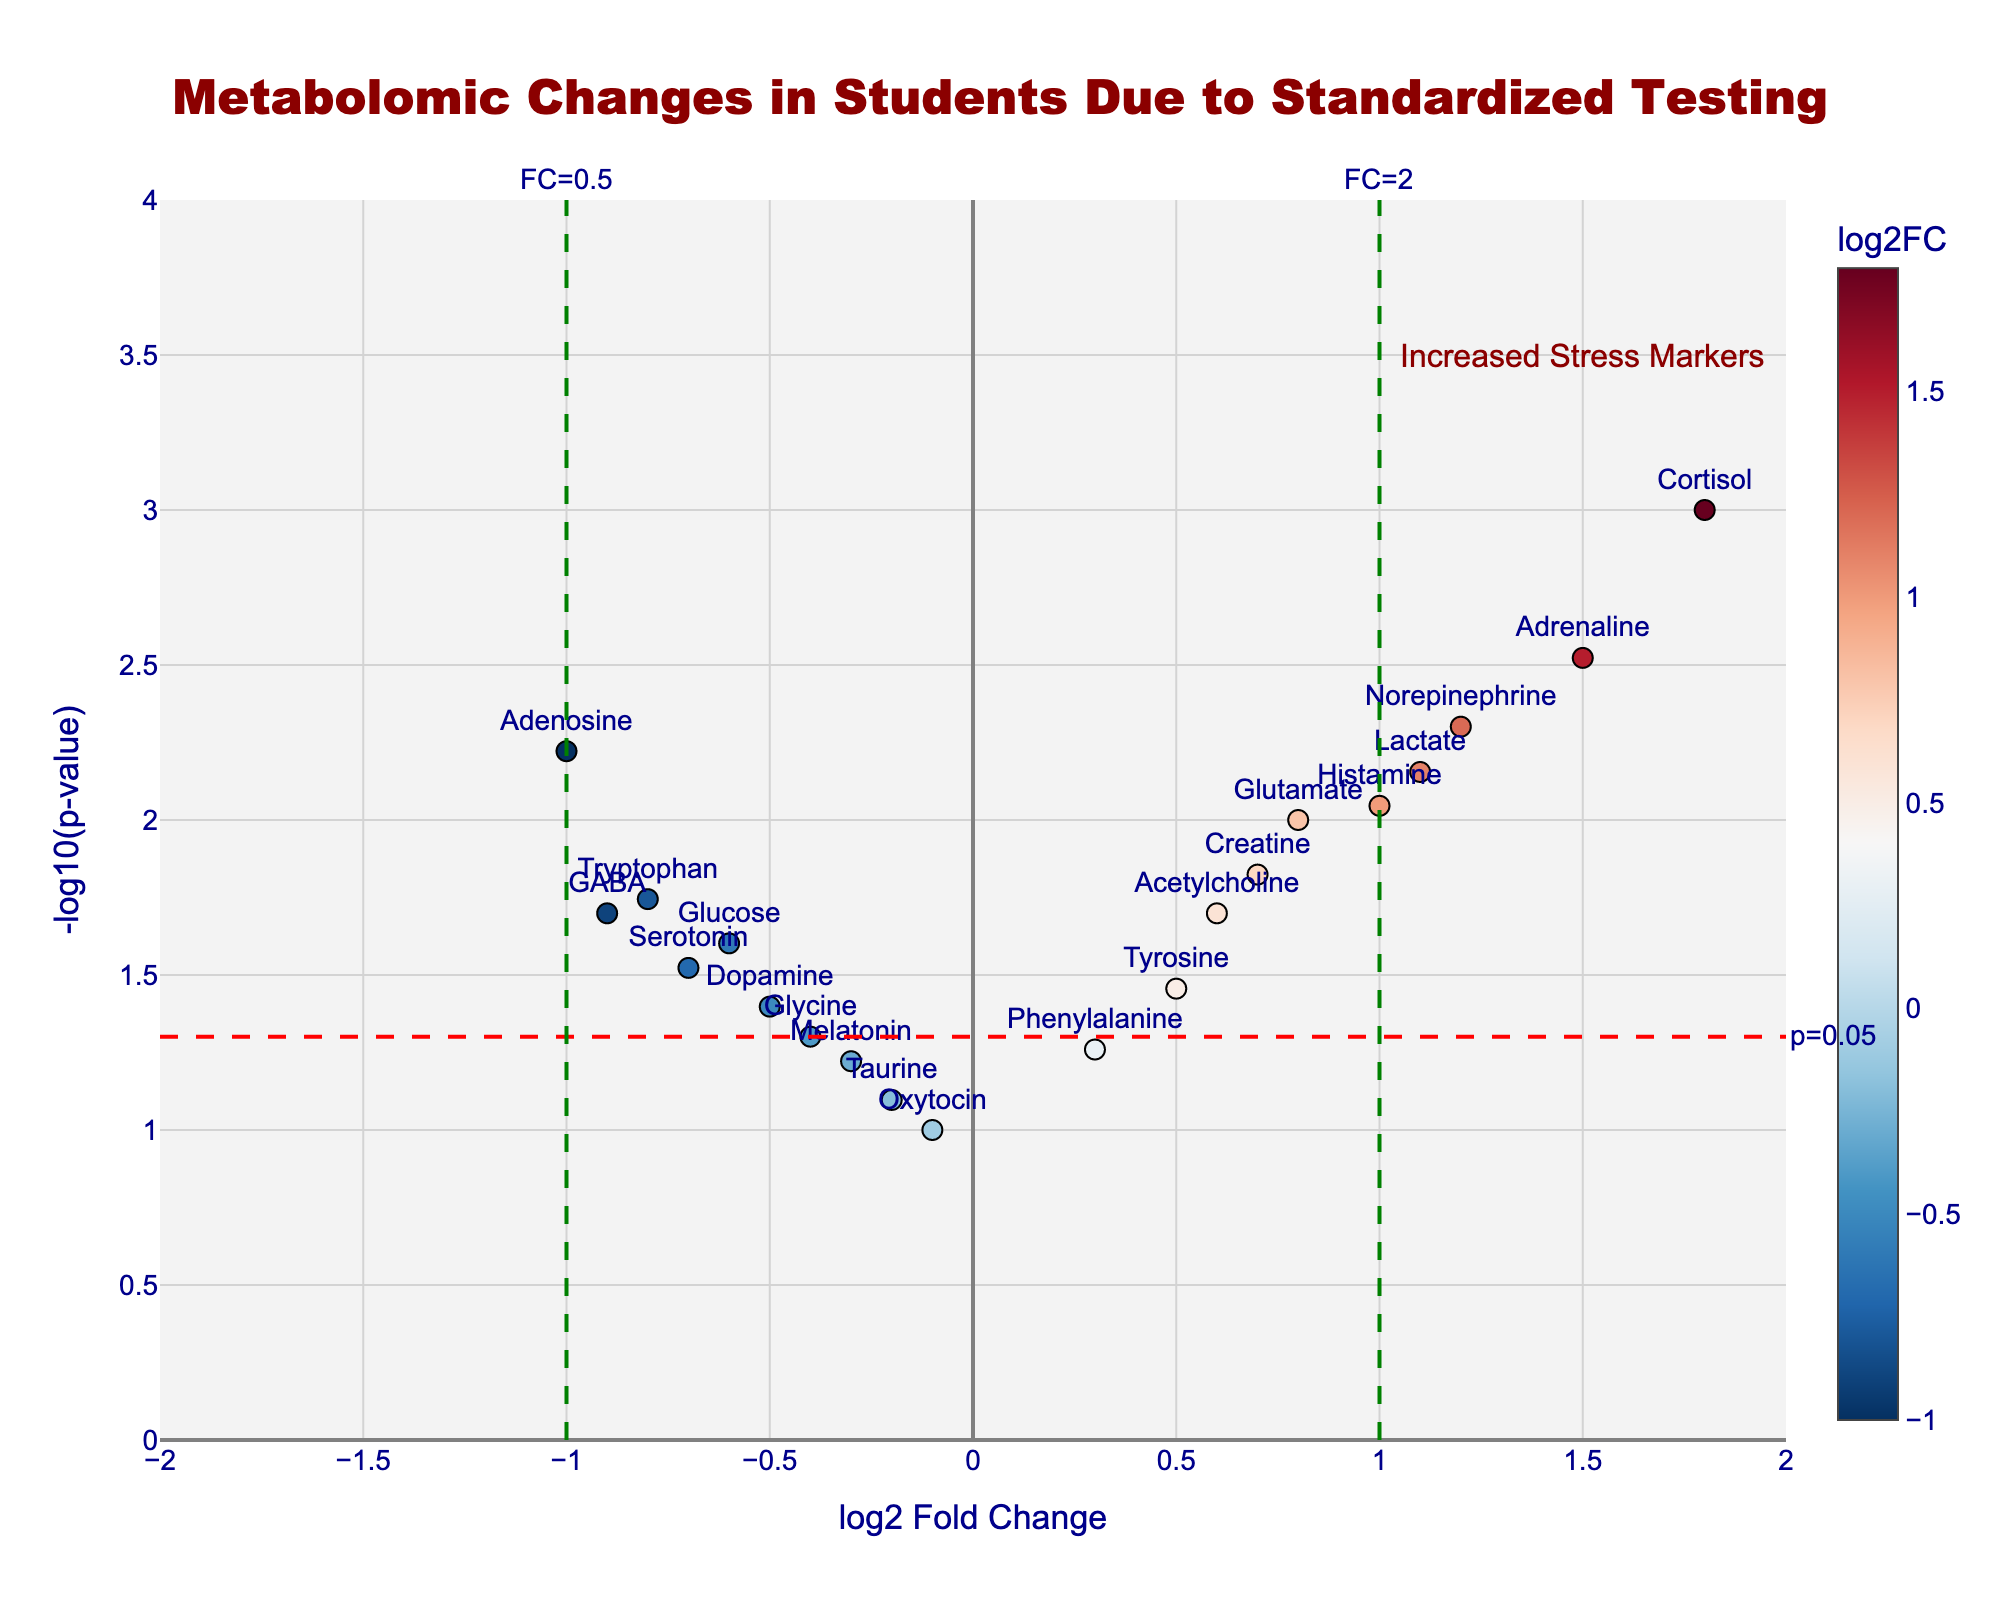What is the title of the plot? The title is prominently displayed at the top of the figure. It reads: "Metabolomic Changes in Students Due to Standardized Testing".
Answer: Metabolomic Changes in Students Due to Standardized Testing Which metabolite has the highest log2 Fold Change? By looking at the x-axis, "Cortisol" is the data point farthest to the right, indicating the highest log2 Fold Change.
Answer: Cortisol What is the range of log2 Fold Change on the x-axis? The x-axis clearly shows the range from -2 to 2.
Answer: -2 to 2 How many metabolites have a p-value less than 0.01? Count the points that are above the horizontal dashed red line at y = -log10(0.05), which is the p-value threshold of 0.01. There are 7 such points (Cortisol, Adrenaline, Norepinephrine, Glutamate, Histamine, Adenosine, Lactate).
Answer: 7 Which group of metabolites is likely to be stress-related based on the annotation? The annotation "Increased Stress Markers" at the top right region of the plot indicates that the metabolites in that area, which include Cortisol and Adrenaline, are likely stress-related.
Answer: Cortisol and Adrenaline What does the dashed horizontal red line represent? The annotation next to the dashed horizontal red line reads "p=0.05", indicating that the line represents the p-value threshold of 0.05 when considering statistical significance.
Answer: p-value threshold of 0.05 Are there any metabolites with a significant decrease in their levels? If so, name them. Look to the left of the vertical axis (log2 Fold Change < 0) and above the red dashed line (p-value < 0.05). Metabolites here indicate a significant decrease. GABA, Serotonin, and Adenosine fit this criteria.
Answer: GABA, Serotonin, Adenosine Which metabolites have a log2 Fold Change between 0.5 and 1 and a p-value less than 0.05? Identify the points within the vertical lines at log2 Fold Change between 0.5 and 1 and above the horizontal dashed line. These points are Glutamate, Creatine, and Acetylcholine.
Answer: Glutamate, Creatine, Acetylcholine Which metabolite(s) hover near the p-value significance threshold of 0.05? Identify data points near the horizontal red line. Melatonin, Glucose, and Glycine are closest to this threshold.
Answer: Melatonin, Glucose, Glycine In what region of the plot would you find metabolites that have an insignificant change in concentration? Metabolites close to the y-axis (log2 Fold Change near 0) and below the dashed red line (p-value > 0.05) indicate insignificant concentration changes. Oxytocin and Phenylalanine fit this description.
Answer: Oxytocin and Phenylalanine 